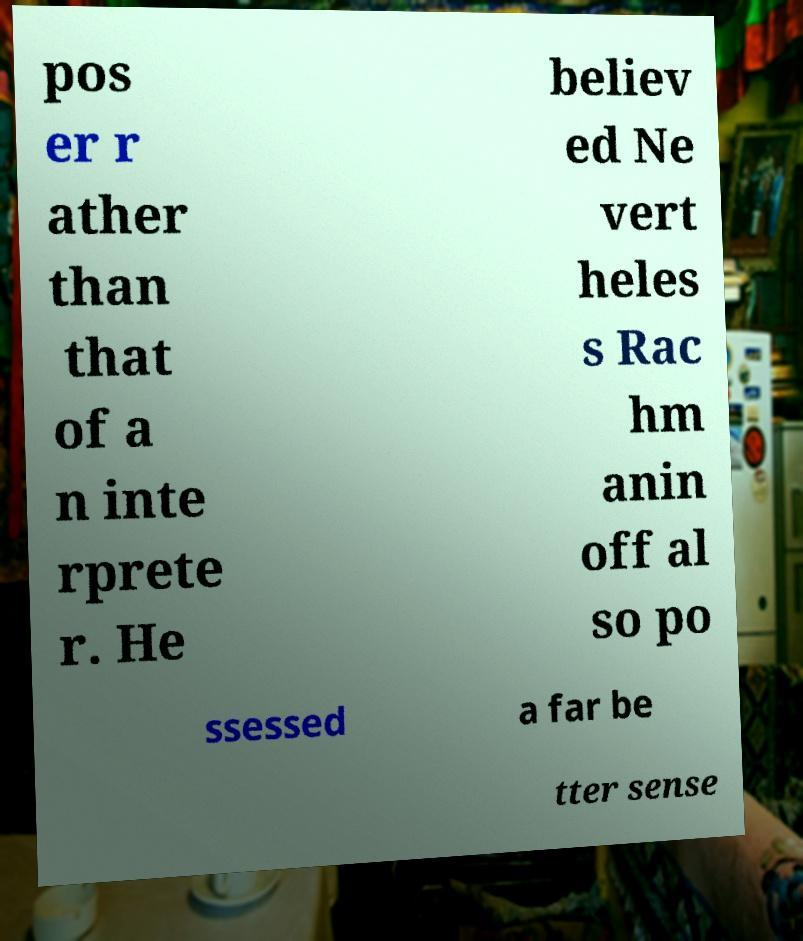For documentation purposes, I need the text within this image transcribed. Could you provide that? pos er r ather than that of a n inte rprete r. He believ ed Ne vert heles s Rac hm anin off al so po ssessed a far be tter sense 